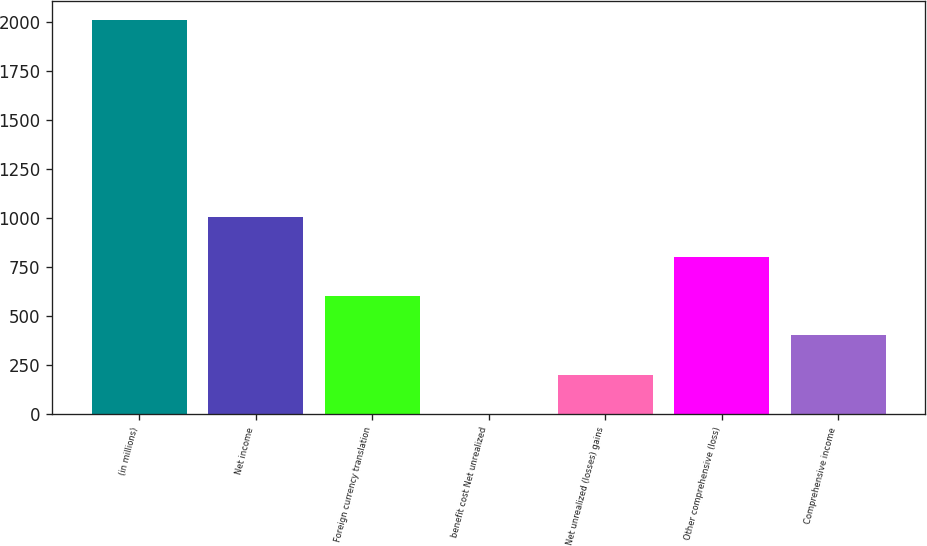Convert chart to OTSL. <chart><loc_0><loc_0><loc_500><loc_500><bar_chart><fcel>(in millions)<fcel>Net income<fcel>Foreign currency translation<fcel>benefit cost Net unrealized<fcel>Net unrealized (losses) gains<fcel>Other comprehensive (loss)<fcel>Comprehensive income<nl><fcel>2008<fcel>1005.1<fcel>603.94<fcel>2.2<fcel>202.78<fcel>804.52<fcel>403.36<nl></chart> 